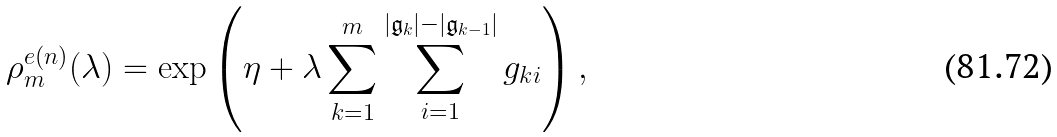Convert formula to latex. <formula><loc_0><loc_0><loc_500><loc_500>\rho ^ { e ( n ) } _ { m } ( \lambda ) = \exp \left ( \eta + \lambda \sum _ { k = 1 } ^ { m } \sum _ { i = 1 } ^ { | \mathfrak { g } _ { k } | - | \mathfrak { g } _ { k - 1 } | } g _ { k i } \right ) ,</formula> 